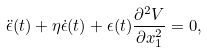<formula> <loc_0><loc_0><loc_500><loc_500>\ddot { \epsilon } ( t ) + \eta \dot { \epsilon } ( t ) + \epsilon ( t ) \frac { \partial ^ { 2 } V } { \partial x _ { 1 } ^ { 2 } } = 0 ,</formula> 